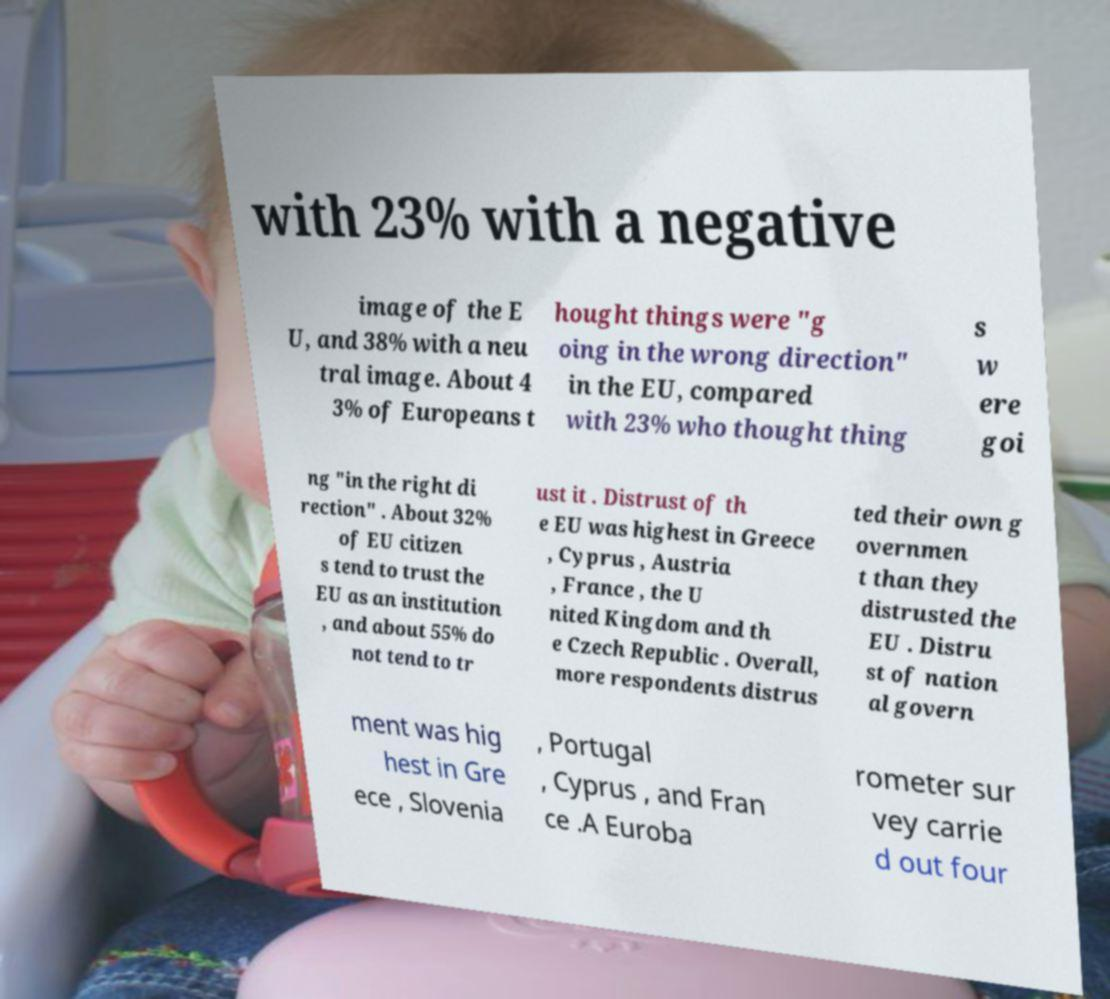For documentation purposes, I need the text within this image transcribed. Could you provide that? with 23% with a negative image of the E U, and 38% with a neu tral image. About 4 3% of Europeans t hought things were "g oing in the wrong direction" in the EU, compared with 23% who thought thing s w ere goi ng "in the right di rection" . About 32% of EU citizen s tend to trust the EU as an institution , and about 55% do not tend to tr ust it . Distrust of th e EU was highest in Greece , Cyprus , Austria , France , the U nited Kingdom and th e Czech Republic . Overall, more respondents distrus ted their own g overnmen t than they distrusted the EU . Distru st of nation al govern ment was hig hest in Gre ece , Slovenia , Portugal , Cyprus , and Fran ce .A Euroba rometer sur vey carrie d out four 